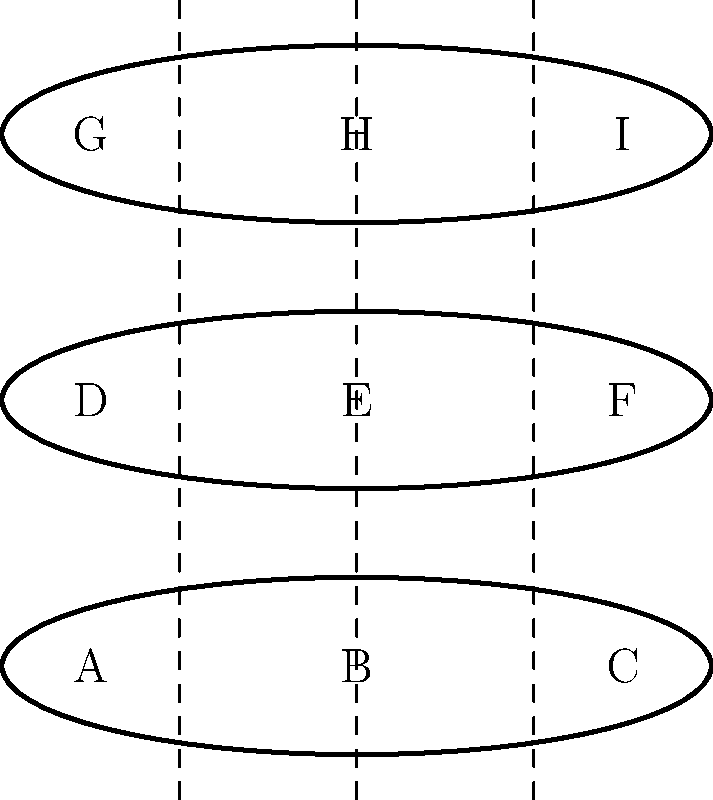Given the cutting pattern shown in the diagram, where three logs are cut into three sections each, how many unique ways can the resulting wood pieces be arranged to form a complete set (one piece from each of the three vertical sections)? Assume that pieces from the same vertical section are interchangeable. To solve this problem, we'll use the multiplication principle from group theory:

1. First, let's identify the groups:
   - Left section: {A, D, G}
   - Middle section: {B, E, H}
   - Right section: {C, F, I}

2. We need to choose one piece from each section to form a complete set.

3. For the left section, we have 3 choices.

4. For the middle section, we again have 3 choices.

5. For the right section, we have 3 choices.

6. According to the multiplication principle, when we have independent choices, we multiply the number of possibilities for each choice:

   $$ 3 \times 3 \times 3 = 27 $$

Therefore, there are 27 unique ways to arrange the wood pieces to form a complete set.
Answer: 27 